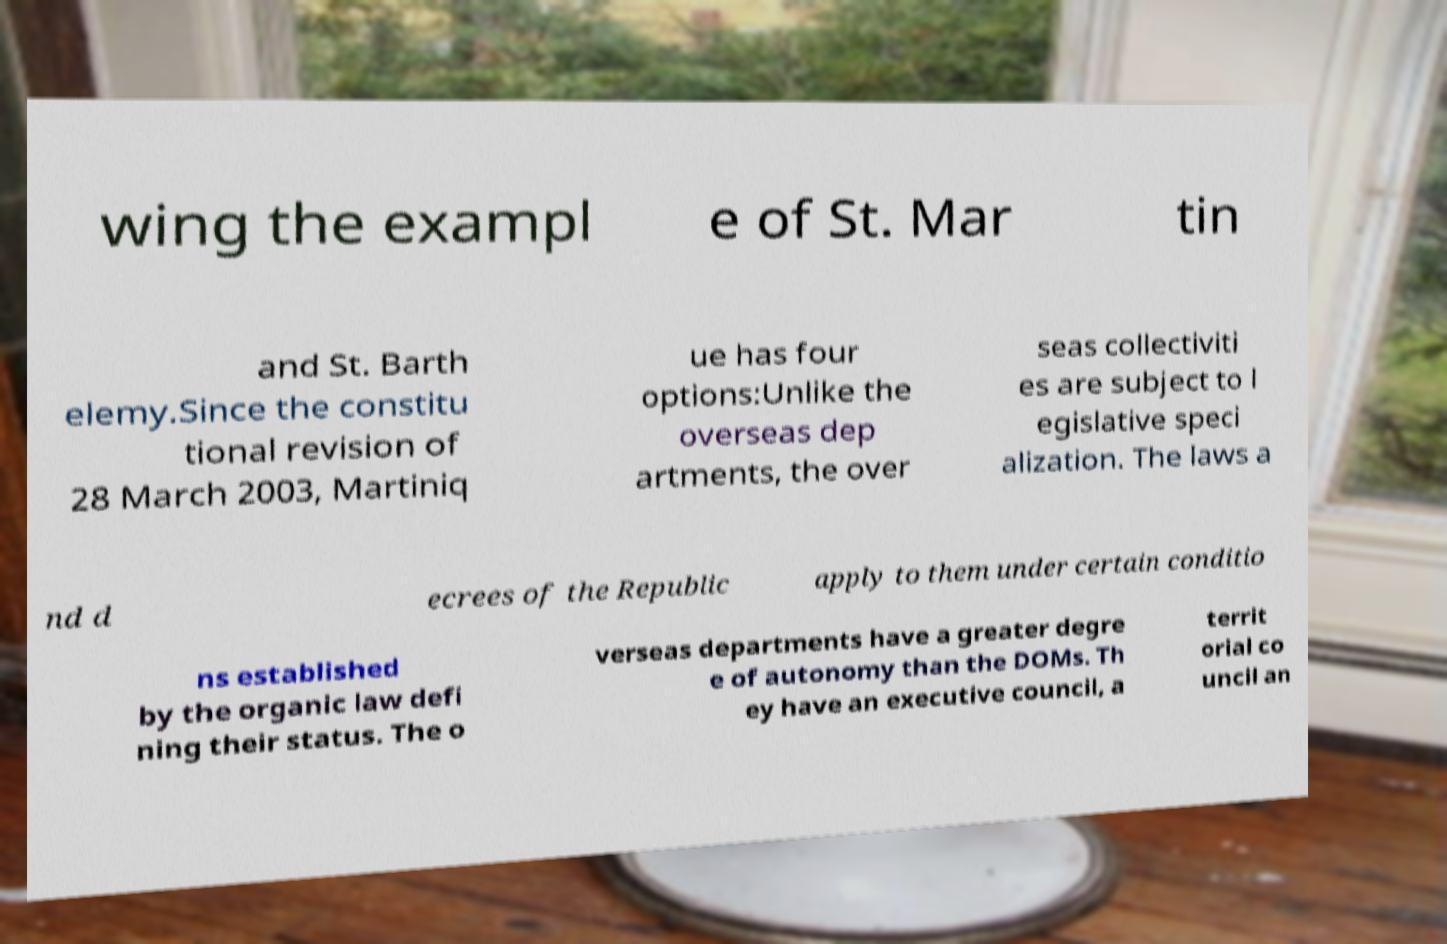For documentation purposes, I need the text within this image transcribed. Could you provide that? wing the exampl e of St. Mar tin and St. Barth elemy.Since the constitu tional revision of 28 March 2003, Martiniq ue has four options:Unlike the overseas dep artments, the over seas collectiviti es are subject to l egislative speci alization. The laws a nd d ecrees of the Republic apply to them under certain conditio ns established by the organic law defi ning their status. The o verseas departments have a greater degre e of autonomy than the DOMs. Th ey have an executive council, a territ orial co uncil an 